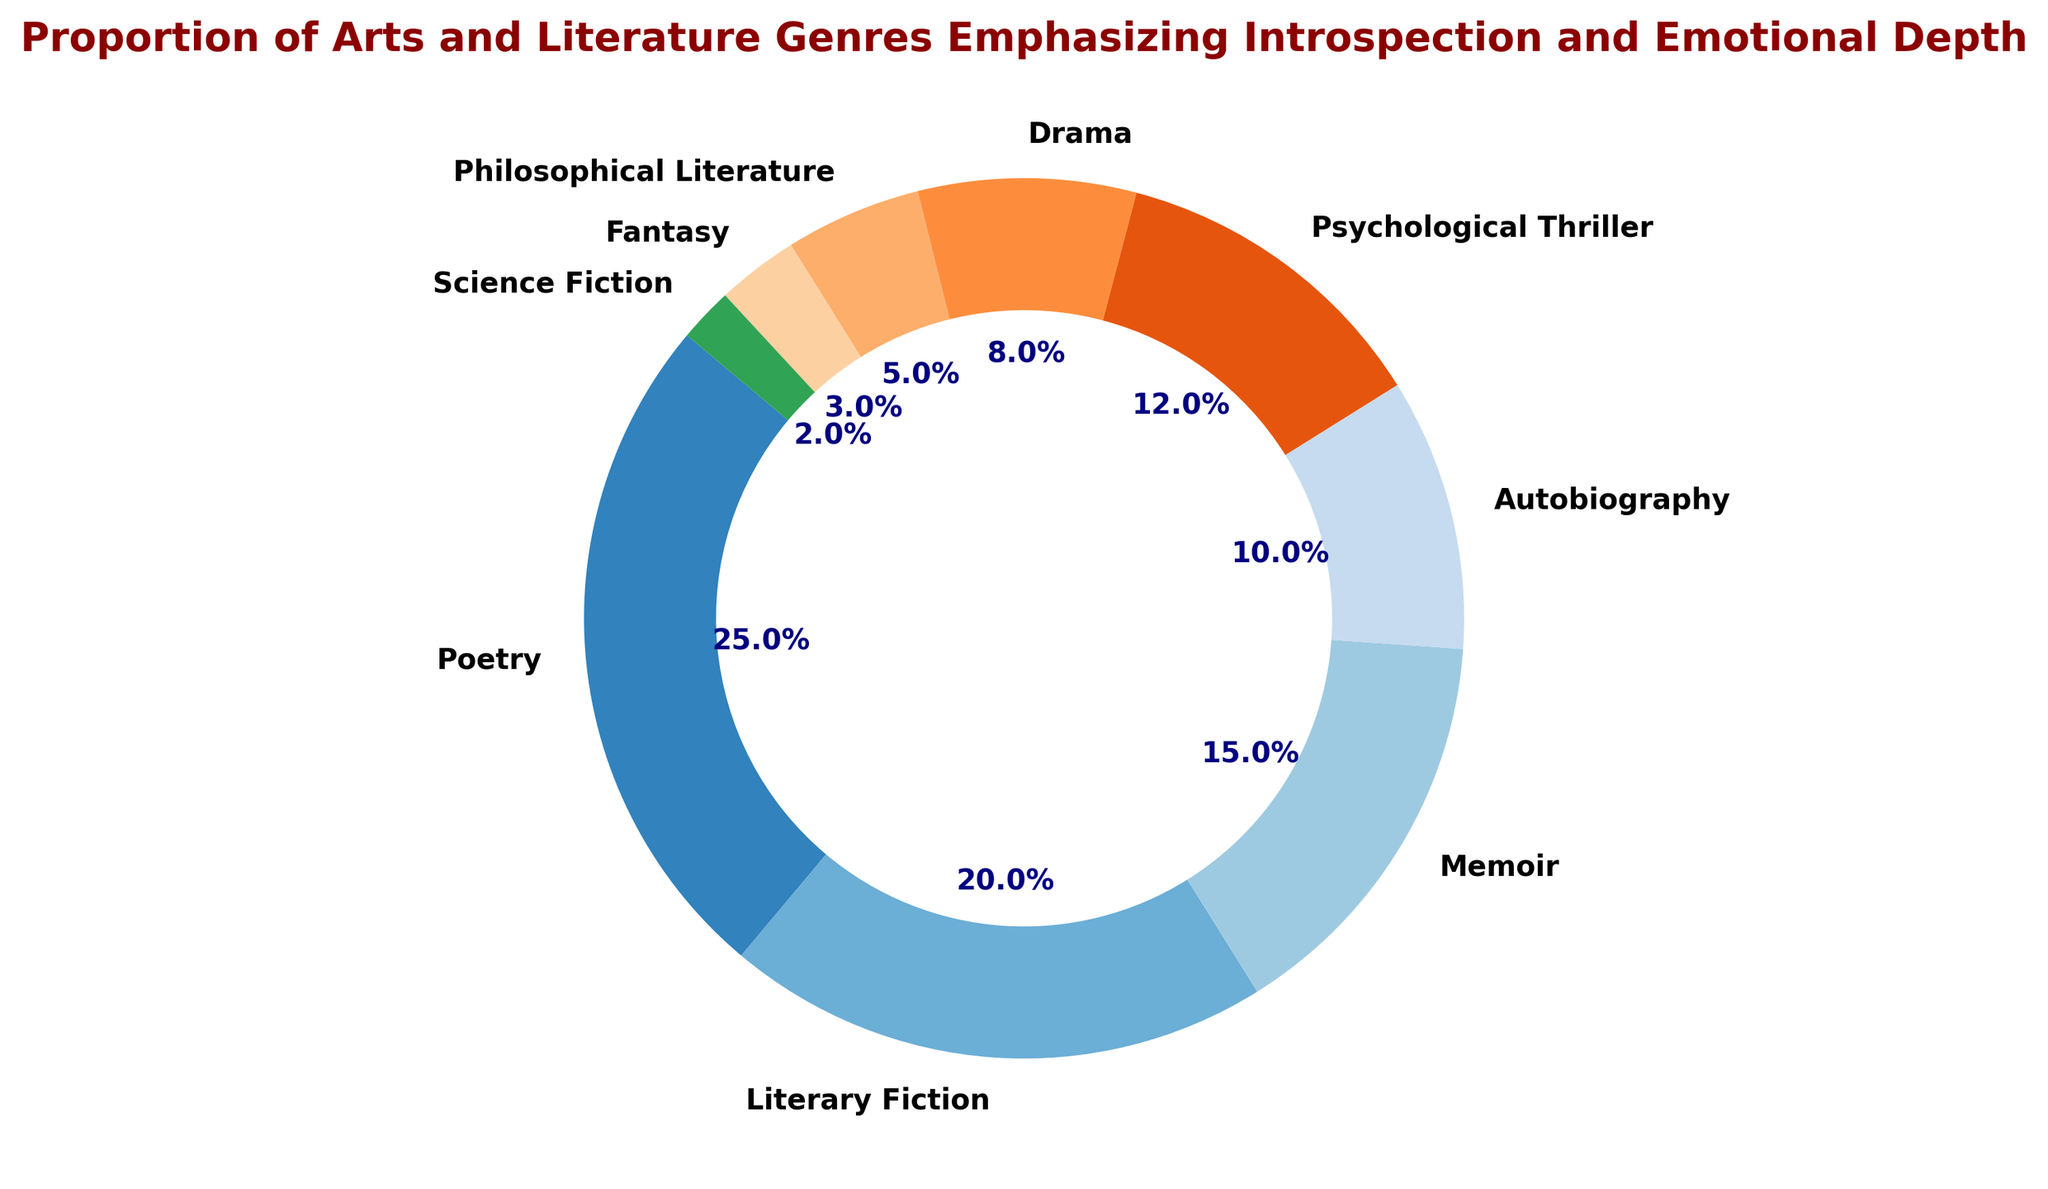What's the genre with the highest percentage of introspective and emotionally deep themes? From the figure, the size of each segment indicates its percentage. The largest segment represents Poetry.
Answer: Poetry Which two genres together make up 30% of the chart? From the figure, Literary Fiction is 20% and Autobiography is 10%. Adding these percentages gives 20% + 10% = 30%.
Answer: Literary Fiction and Autobiography How does the percentage of Drama compare to that of Psychological Thriller? From the figure, Drama is 8% while Psychological Thriller is 12%. 12% is greater than 8%.
Answer: Psychological Thriller has a higher percentage than Drama What is the combined percentage of genres that are under 10%? From the figure, the genres under 10% are Autobiography (10%), Drama (8%), Philosophical Literature (5%), Fantasy (3%), and Science Fiction (2%). Adding these percentages gives 10% + 8% + 5% + 3% + 2% = 28%.
Answer: 28% What is the visual cue used to differentiate the genres in the ring chart? The ring chart uses different colors to visually distinguish between the genres.
Answer: Different colors Which genres together form less than half of the total percentage? From the figure, we need to find the genres summing up to less than 50%. Autobiography (10%), Drama (8%), Philosophical Literature (5%), Fantasy (3%), and Science Fiction (2%) together sum up to 28%.
Answer: Autobiography, Drama, Philosophical Literature, Fantasy, Science Fiction By how much does the percentage of Memoir exceed that of Fantasy? From the figure, Memoir is 15% and Fantasy is 3%. The difference is 15% - 3% = 12%.
Answer: 12% What percentage of the chart is made up by the top three highest genres? From the figure, the top three highest genres are Poetry (25%), Literary Fiction (20%), and Memoir (15%). Adding these percentages gives 25% + 20% + 15% = 60%.
Answer: 60% Which genre represents less than 5% of the total in the chart? From the figure, the genre that represents less than 5% is Science Fiction.
Answer: Science Fiction Is the sum percentage of Memoir and Psychological Thriller more or less than the sum of Drama and Philosophical Literature? Memoir and Psychological Thriller sum up to 15% + 12% = 27%. Drama and Philosophical Literature sum up to 8% + 5% = 13%. 27% is greater than 13%.
Answer: More 